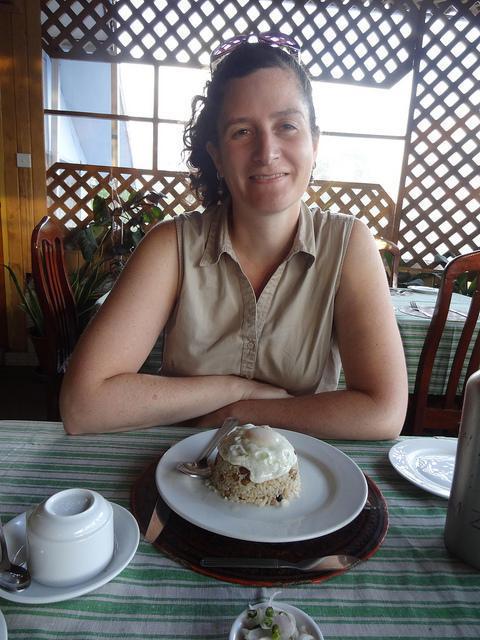How many dining tables are there?
Give a very brief answer. 2. How many chairs can you see?
Give a very brief answer. 2. 